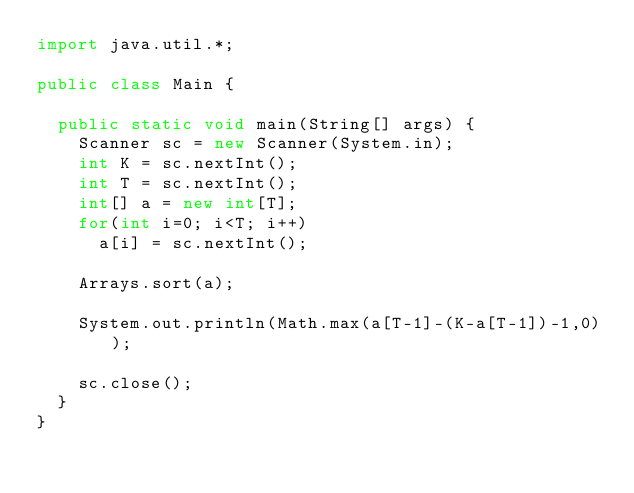Convert code to text. <code><loc_0><loc_0><loc_500><loc_500><_Java_>import java.util.*;

public class Main {

	public static void main(String[] args) {
		Scanner sc = new Scanner(System.in);
		int K = sc.nextInt();
		int T = sc.nextInt();
		int[] a = new int[T];
		for(int i=0; i<T; i++)
			a[i] = sc.nextInt();
		
		Arrays.sort(a);
		
		System.out.println(Math.max(a[T-1]-(K-a[T-1])-1,0));
		
		sc.close();
	}
}
</code> 